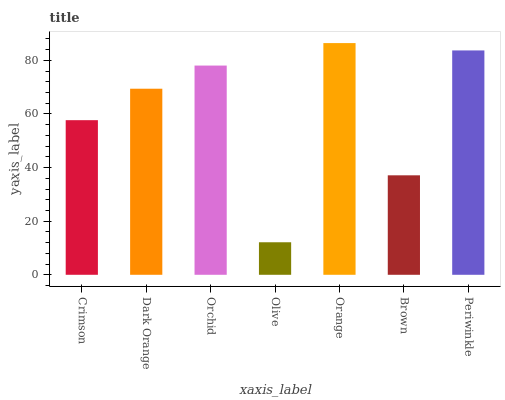Is Olive the minimum?
Answer yes or no. Yes. Is Orange the maximum?
Answer yes or no. Yes. Is Dark Orange the minimum?
Answer yes or no. No. Is Dark Orange the maximum?
Answer yes or no. No. Is Dark Orange greater than Crimson?
Answer yes or no. Yes. Is Crimson less than Dark Orange?
Answer yes or no. Yes. Is Crimson greater than Dark Orange?
Answer yes or no. No. Is Dark Orange less than Crimson?
Answer yes or no. No. Is Dark Orange the high median?
Answer yes or no. Yes. Is Dark Orange the low median?
Answer yes or no. Yes. Is Periwinkle the high median?
Answer yes or no. No. Is Crimson the low median?
Answer yes or no. No. 